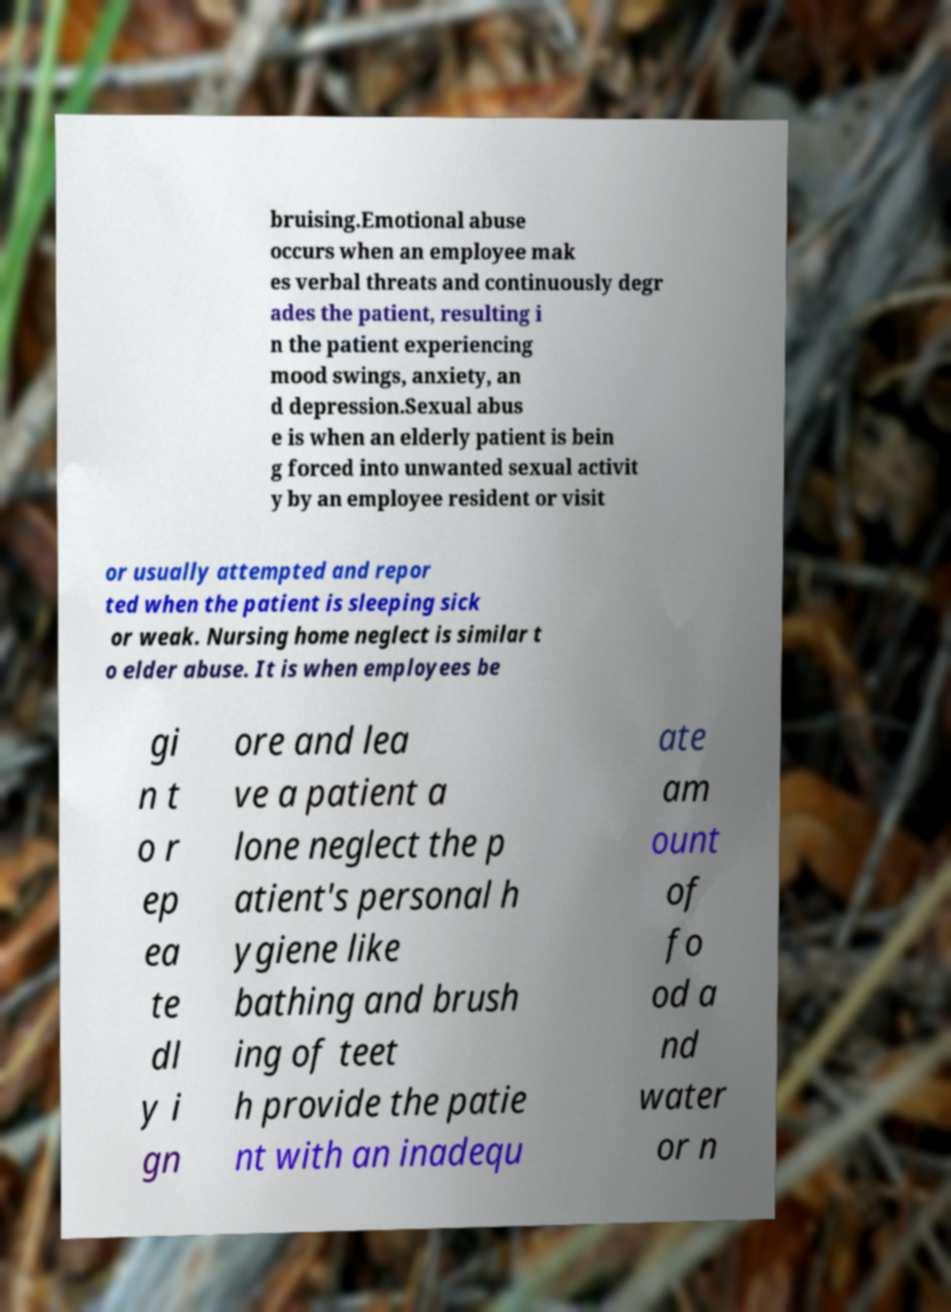Can you read and provide the text displayed in the image?This photo seems to have some interesting text. Can you extract and type it out for me? bruising.Emotional abuse occurs when an employee mak es verbal threats and continuously degr ades the patient, resulting i n the patient experiencing mood swings, anxiety, an d depression.Sexual abus e is when an elderly patient is bein g forced into unwanted sexual activit y by an employee resident or visit or usually attempted and repor ted when the patient is sleeping sick or weak. Nursing home neglect is similar t o elder abuse. It is when employees be gi n t o r ep ea te dl y i gn ore and lea ve a patient a lone neglect the p atient's personal h ygiene like bathing and brush ing of teet h provide the patie nt with an inadequ ate am ount of fo od a nd water or n 